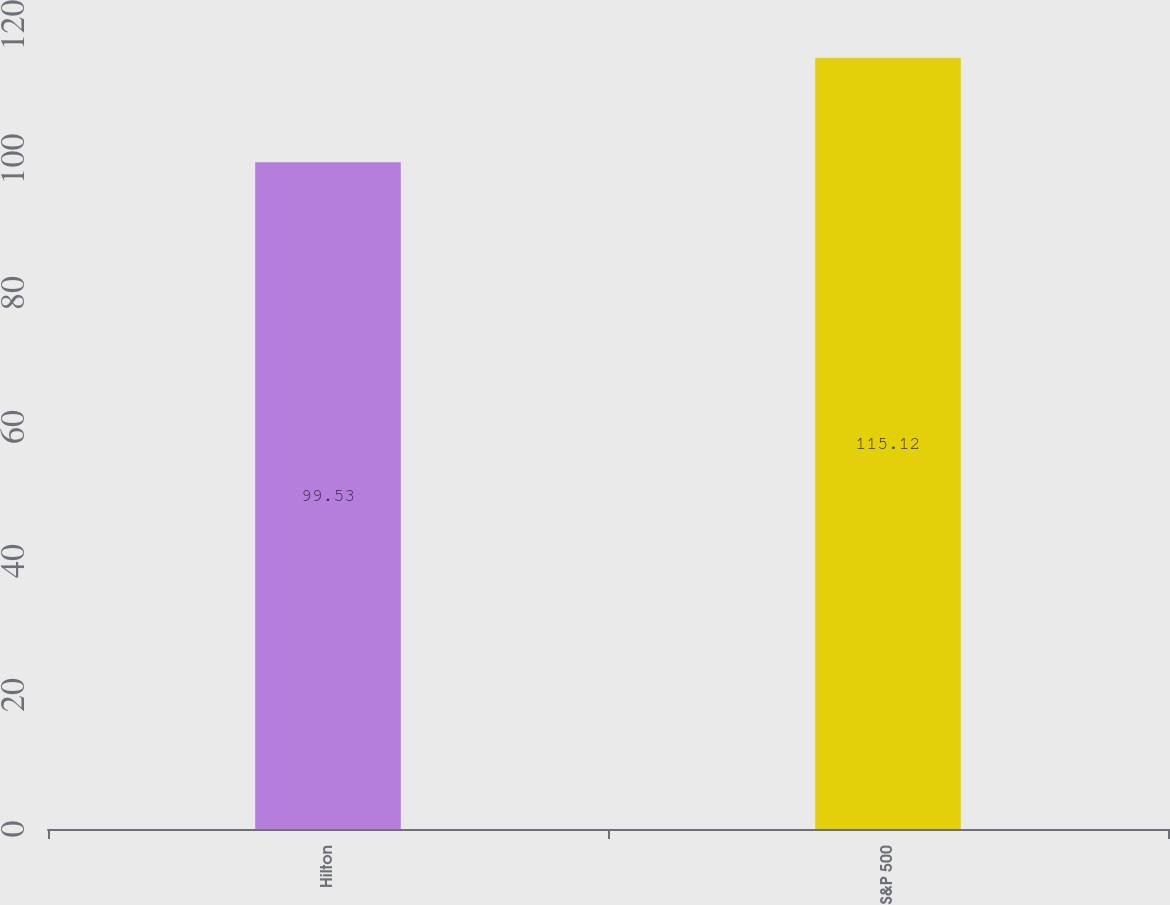Convert chart to OTSL. <chart><loc_0><loc_0><loc_500><loc_500><bar_chart><fcel>Hilton<fcel>S&P 500<nl><fcel>99.53<fcel>115.12<nl></chart> 